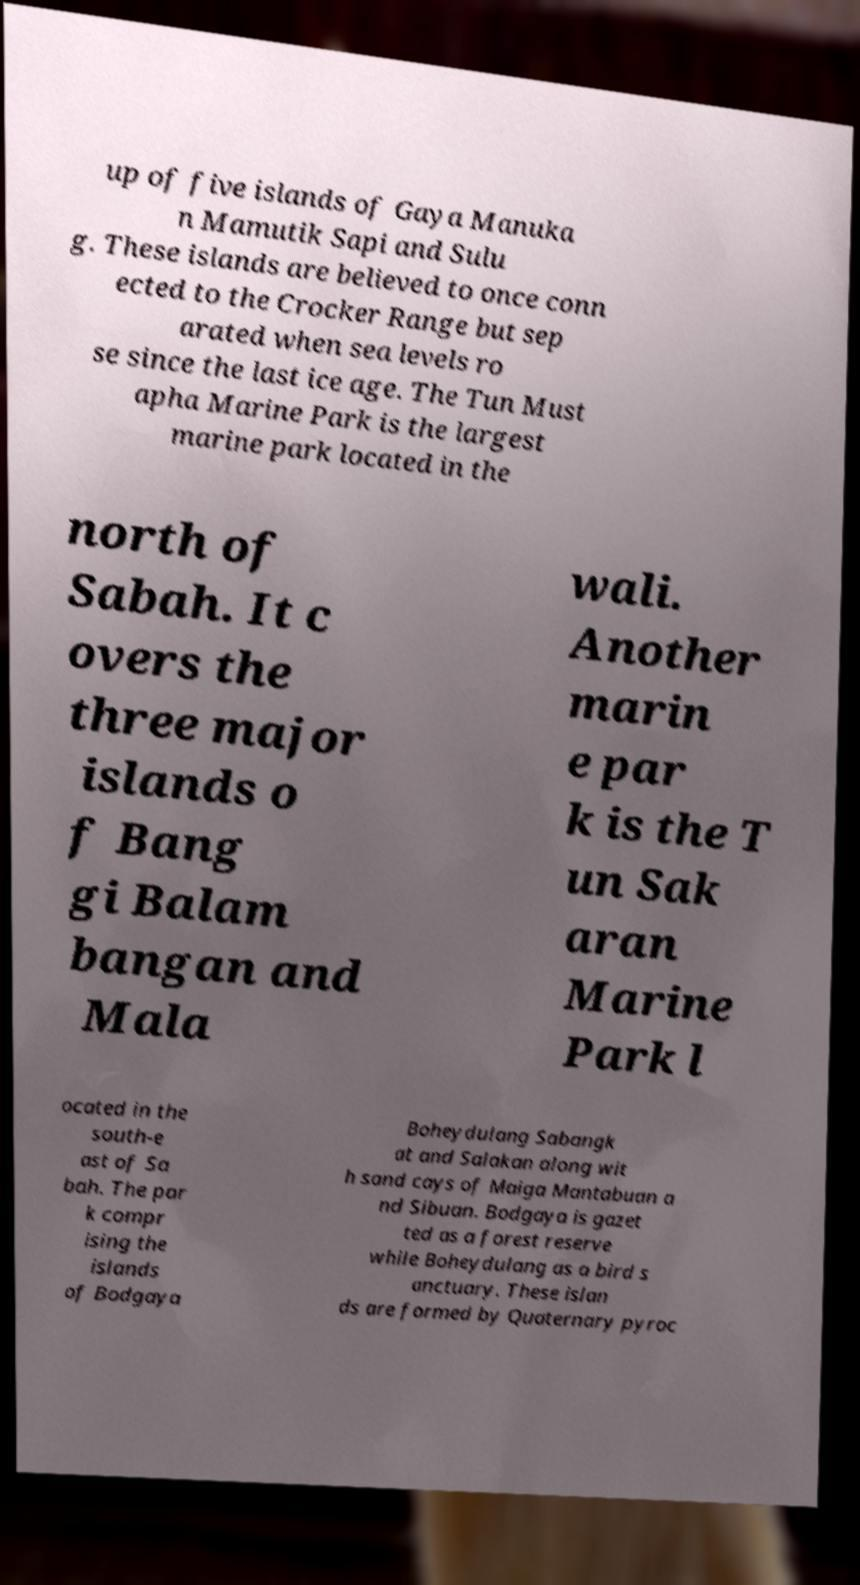For documentation purposes, I need the text within this image transcribed. Could you provide that? up of five islands of Gaya Manuka n Mamutik Sapi and Sulu g. These islands are believed to once conn ected to the Crocker Range but sep arated when sea levels ro se since the last ice age. The Tun Must apha Marine Park is the largest marine park located in the north of Sabah. It c overs the three major islands o f Bang gi Balam bangan and Mala wali. Another marin e par k is the T un Sak aran Marine Park l ocated in the south-e ast of Sa bah. The par k compr ising the islands of Bodgaya Boheydulang Sabangk at and Salakan along wit h sand cays of Maiga Mantabuan a nd Sibuan. Bodgaya is gazet ted as a forest reserve while Boheydulang as a bird s anctuary. These islan ds are formed by Quaternary pyroc 